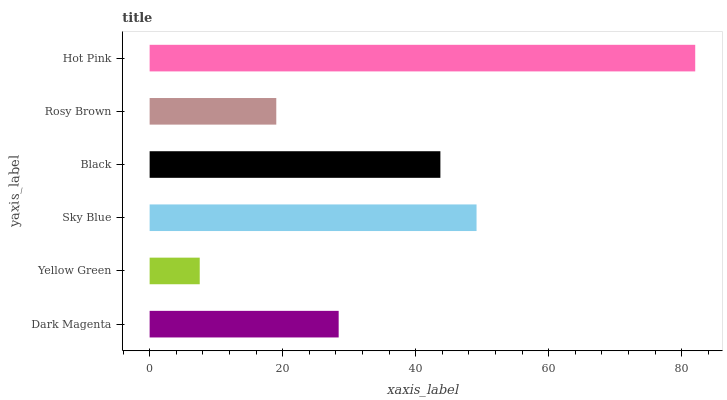Is Yellow Green the minimum?
Answer yes or no. Yes. Is Hot Pink the maximum?
Answer yes or no. Yes. Is Sky Blue the minimum?
Answer yes or no. No. Is Sky Blue the maximum?
Answer yes or no. No. Is Sky Blue greater than Yellow Green?
Answer yes or no. Yes. Is Yellow Green less than Sky Blue?
Answer yes or no. Yes. Is Yellow Green greater than Sky Blue?
Answer yes or no. No. Is Sky Blue less than Yellow Green?
Answer yes or no. No. Is Black the high median?
Answer yes or no. Yes. Is Dark Magenta the low median?
Answer yes or no. Yes. Is Yellow Green the high median?
Answer yes or no. No. Is Rosy Brown the low median?
Answer yes or no. No. 